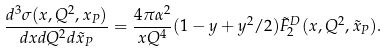Convert formula to latex. <formula><loc_0><loc_0><loc_500><loc_500>\frac { d ^ { 3 } \sigma ( x , Q ^ { 2 } , x _ { P } ) } { d x d Q ^ { 2 } d \tilde { x } _ { P } } = \frac { 4 \pi \alpha ^ { 2 } } { x Q ^ { 4 } } ( 1 - y + y ^ { 2 } / 2 ) \tilde { F } _ { 2 } ^ { D } ( x , Q ^ { 2 } , \tilde { x } _ { P } ) .</formula> 